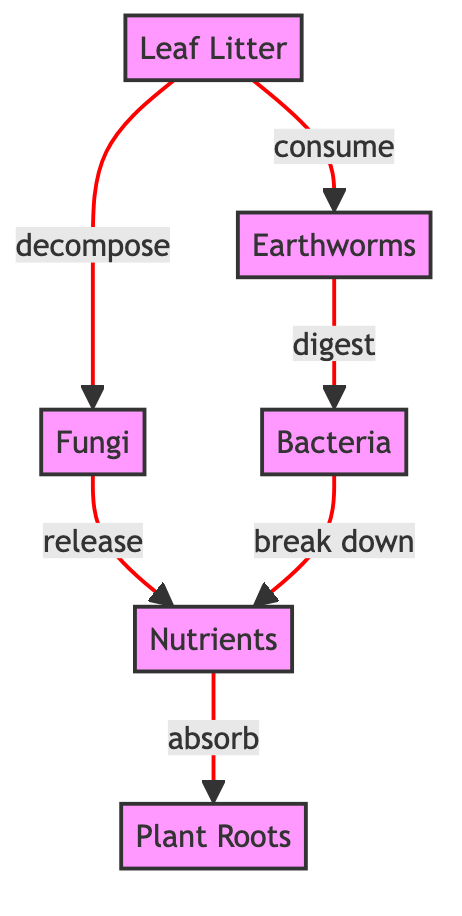What is the first node in the diagram? The diagram starts with "Leaf Litter," which is the first node labeled as 1.
Answer: Leaf Litter How many nodes are represented in the diagram? The diagram contains six distinct nodes representing different elements of the food chain. They are Leaf Litter, Earthworms, Fungi, Bacteria, Nutrients, and Plant Roots.
Answer: 6 What do Earthworms consume? According to the diagram, Earthworms consume Leaf Litter, which is indicated by the directed edge labeled "consume" pointing from Leaf Litter to Earthworms.
Answer: Leaf Litter Which node releases Nutrients? Fungi is identified in the diagram as the node that releases Nutrients, as shown by the directed edge labeled "release" pointing from Fungi to Nutrients.
Answer: Fungi What role do Bacteria play in the nutrient cycle? Bacteria break down organic matter into Nutrients, as indicated by the directed edge labeled "break down" that leads from Bacteria to Nutrients.
Answer: Break down Which nodes release Nutrients in the diagram? The diagram shows that both Fungi and Bacteria release Nutrients, with directed edges leading from each of them to the Nutrients node.
Answer: Fungi and Bacteria What is the relationship between Nutrients and Plant Roots? The diagram illustrates that Plant Roots absorb Nutrients, as indicated by the edge labeled "absorb" connecting Nutrients to Plant Roots.
Answer: Absorb In total, how many edges are present in the diagram? There are five directed edges in the diagram, representing the relationships between the various nodes. Each connection is a flow indicating how organic matter is processed and nutrients are cycled.
Answer: 5 What do Earthworms digest? Earthworms digest Bacteria, as shown by the directed edge labeled "digest" connecting Earthworms to Bacteria in the diagram.
Answer: Bacteria 